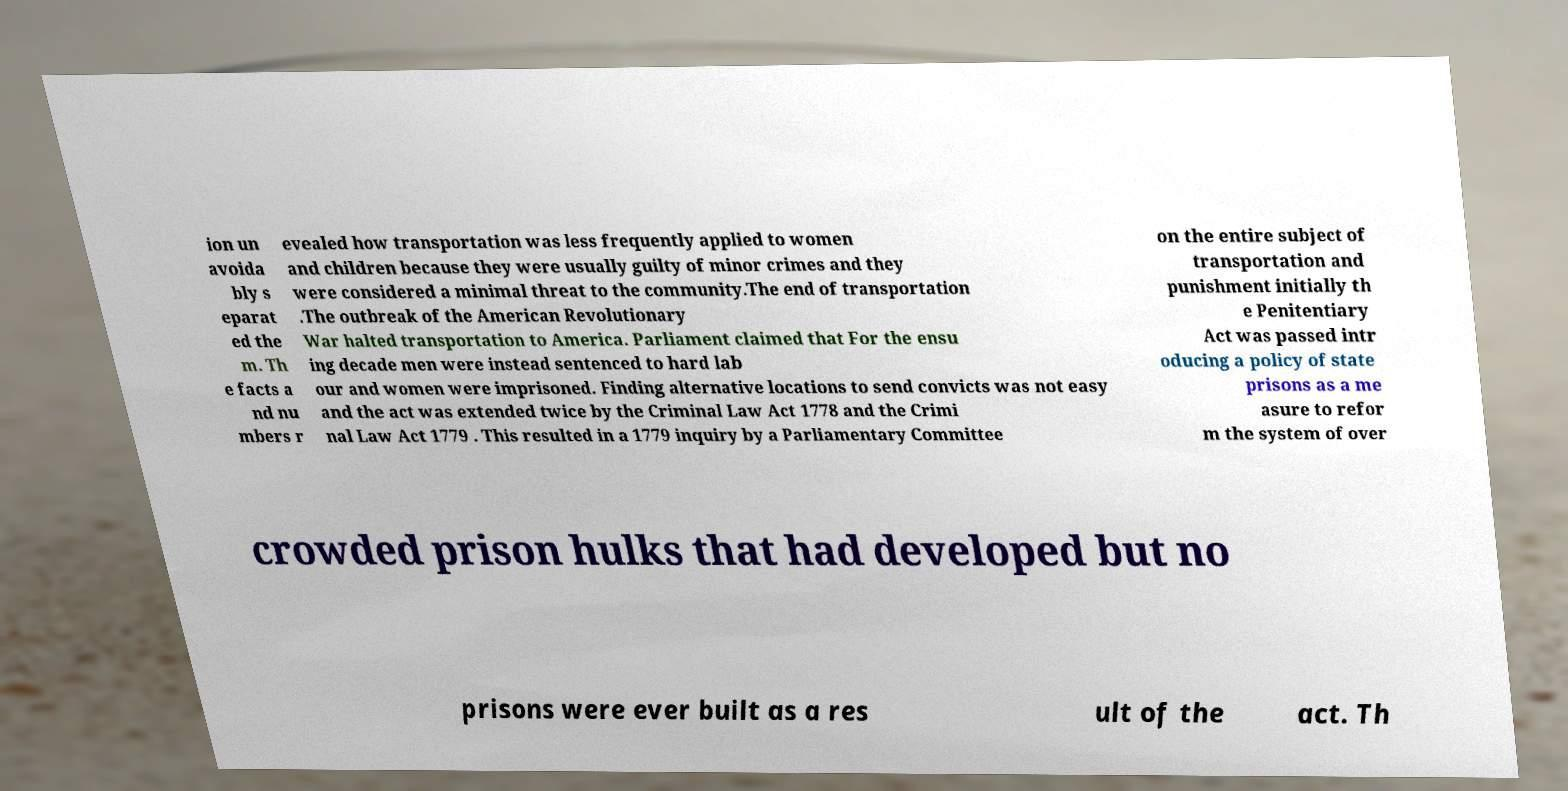Please identify and transcribe the text found in this image. ion un avoida bly s eparat ed the m. Th e facts a nd nu mbers r evealed how transportation was less frequently applied to women and children because they were usually guilty of minor crimes and they were considered a minimal threat to the community.The end of transportation .The outbreak of the American Revolutionary War halted transportation to America. Parliament claimed that For the ensu ing decade men were instead sentenced to hard lab our and women were imprisoned. Finding alternative locations to send convicts was not easy and the act was extended twice by the Criminal Law Act 1778 and the Crimi nal Law Act 1779 . This resulted in a 1779 inquiry by a Parliamentary Committee on the entire subject of transportation and punishment initially th e Penitentiary Act was passed intr oducing a policy of state prisons as a me asure to refor m the system of over crowded prison hulks that had developed but no prisons were ever built as a res ult of the act. Th 